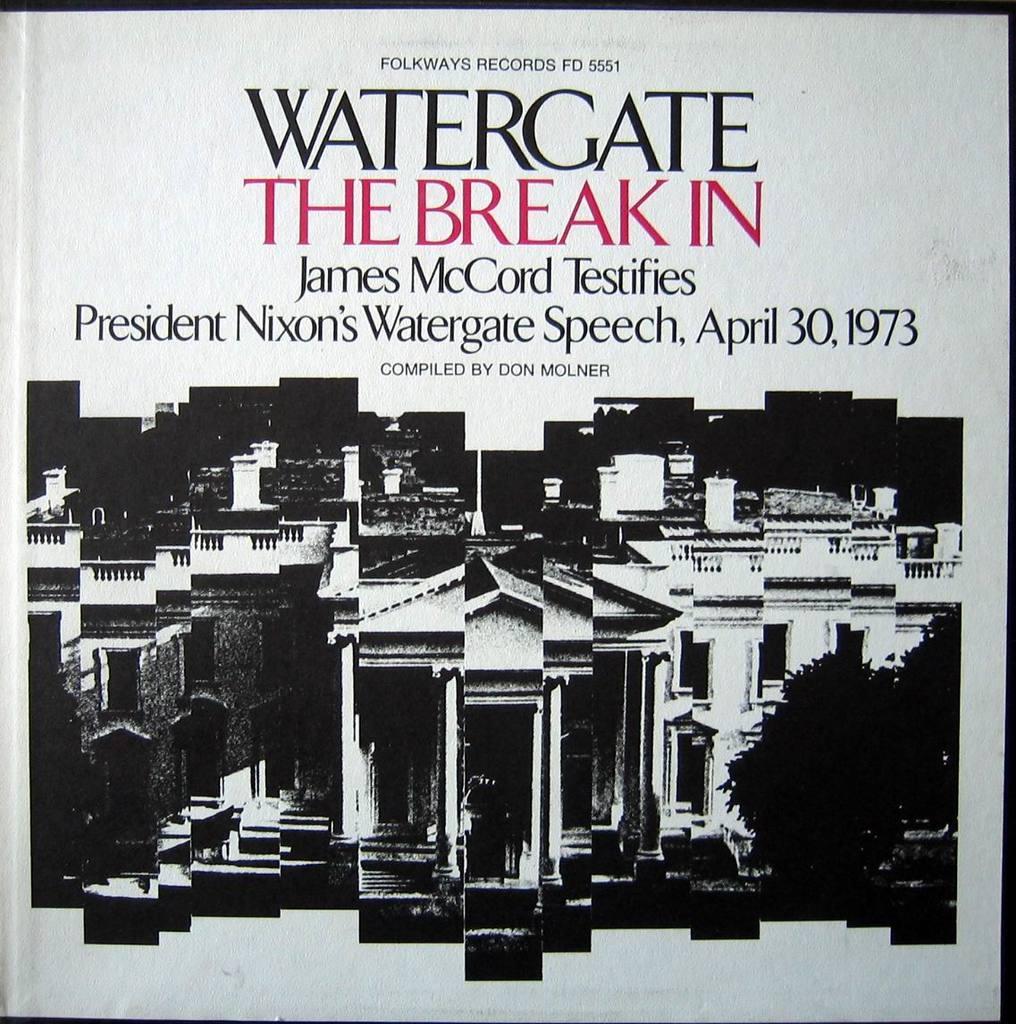How would you summarize this image in a sentence or two? In this image we can see a poster which includes some images of buildings and trees. We can see some text written on it. 